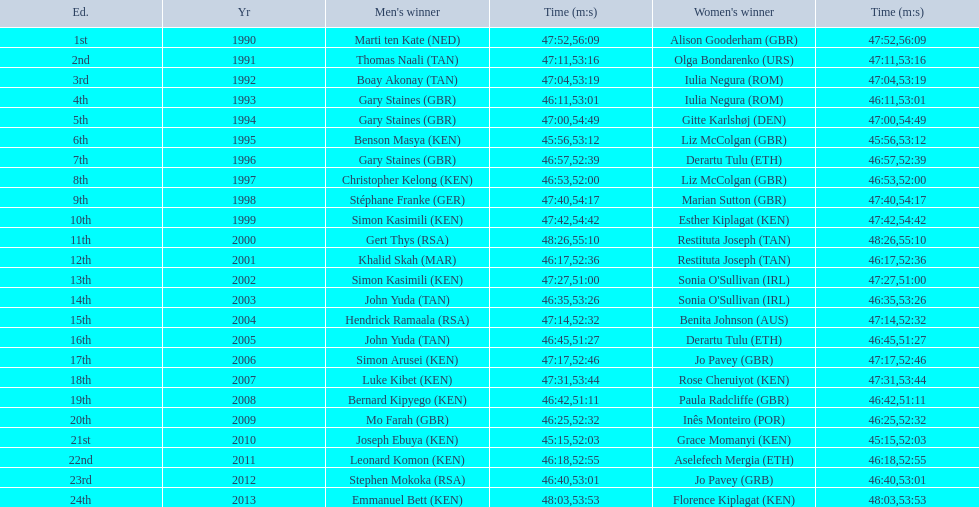How long did sonia o'sullivan take to finish in 2003? 53:26. 